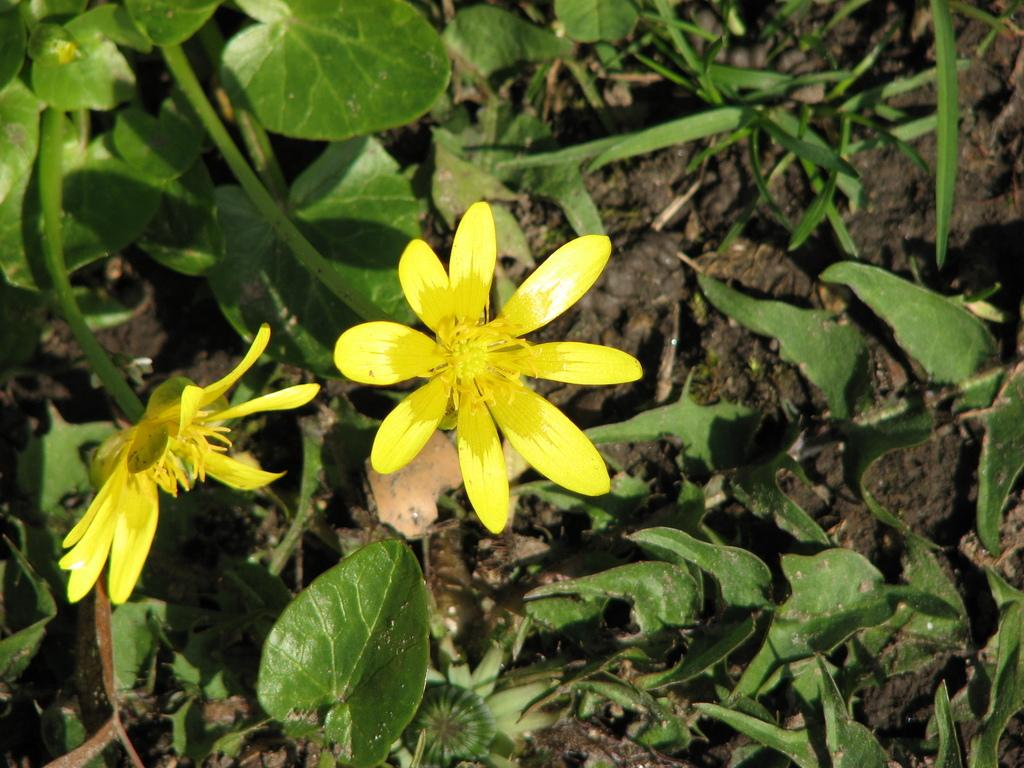What type of natural material is present in the image? There is soil in the image. What other plant-related elements can be seen in the image? There are leaves, stems, and flowers in the image. What type of art tool is used to paint the flowers in the image? There is no art tool or painting depicted in the image; it features actual soil, leaves, stems, and flowers. 